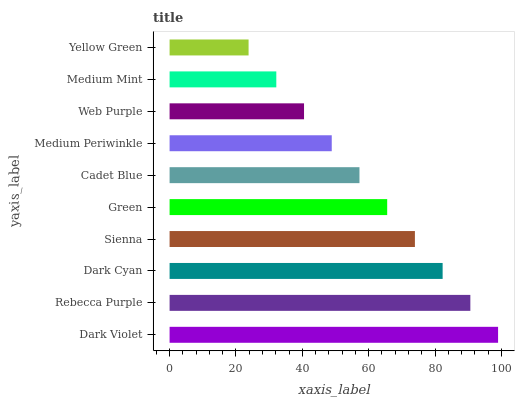Is Yellow Green the minimum?
Answer yes or no. Yes. Is Dark Violet the maximum?
Answer yes or no. Yes. Is Rebecca Purple the minimum?
Answer yes or no. No. Is Rebecca Purple the maximum?
Answer yes or no. No. Is Dark Violet greater than Rebecca Purple?
Answer yes or no. Yes. Is Rebecca Purple less than Dark Violet?
Answer yes or no. Yes. Is Rebecca Purple greater than Dark Violet?
Answer yes or no. No. Is Dark Violet less than Rebecca Purple?
Answer yes or no. No. Is Green the high median?
Answer yes or no. Yes. Is Cadet Blue the low median?
Answer yes or no. Yes. Is Rebecca Purple the high median?
Answer yes or no. No. Is Dark Violet the low median?
Answer yes or no. No. 